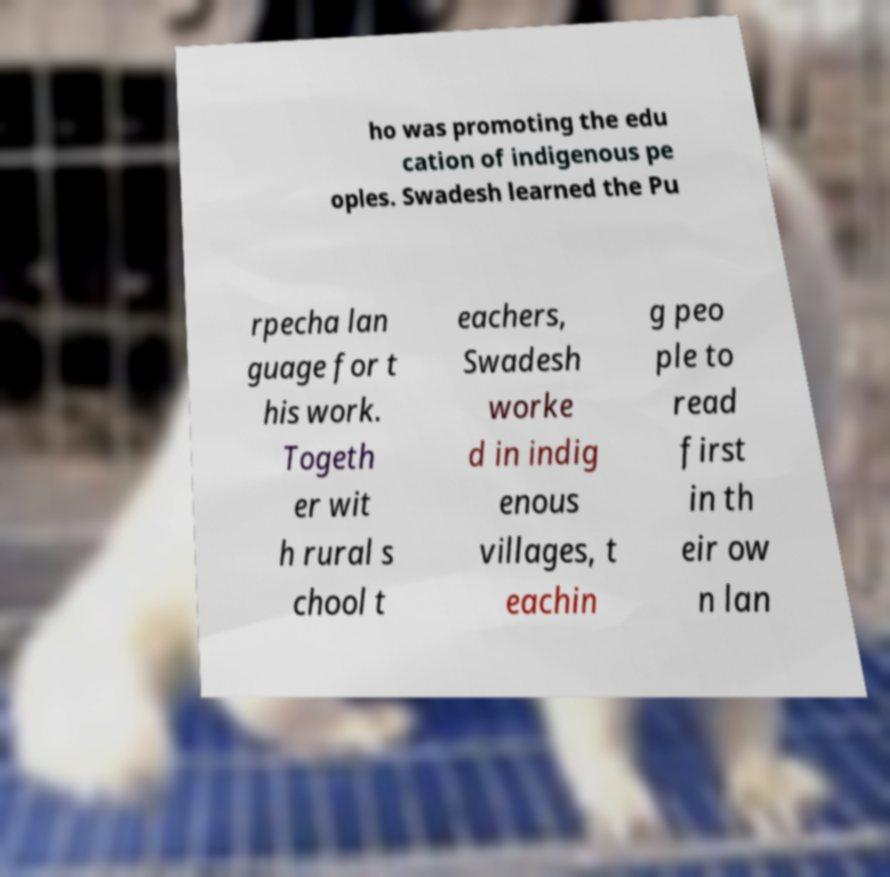There's text embedded in this image that I need extracted. Can you transcribe it verbatim? ho was promoting the edu cation of indigenous pe oples. Swadesh learned the Pu rpecha lan guage for t his work. Togeth er wit h rural s chool t eachers, Swadesh worke d in indig enous villages, t eachin g peo ple to read first in th eir ow n lan 